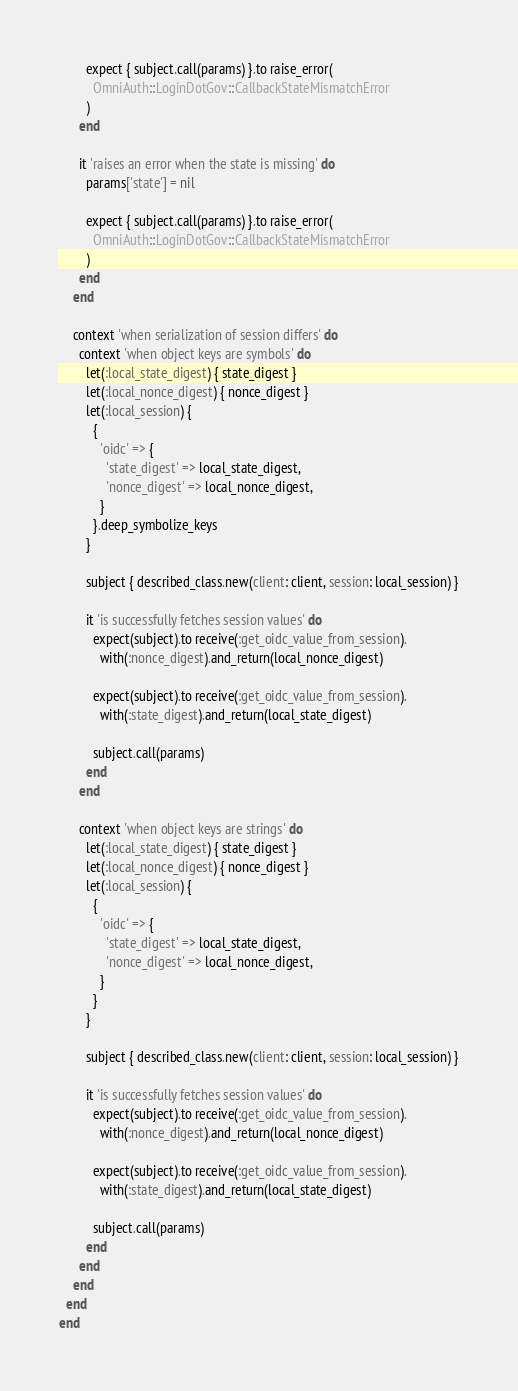Convert code to text. <code><loc_0><loc_0><loc_500><loc_500><_Ruby_>        expect { subject.call(params) }.to raise_error(
          OmniAuth::LoginDotGov::CallbackStateMismatchError
        )
      end

      it 'raises an error when the state is missing' do
        params['state'] = nil

        expect { subject.call(params) }.to raise_error(
          OmniAuth::LoginDotGov::CallbackStateMismatchError
        )
      end
    end

    context 'when serialization of session differs' do
      context 'when object keys are symbols' do
        let(:local_state_digest) { state_digest }
        let(:local_nonce_digest) { nonce_digest }
        let(:local_session) {
          {
            'oidc' => {
              'state_digest' => local_state_digest,
              'nonce_digest' => local_nonce_digest,
            }
          }.deep_symbolize_keys
        }

        subject { described_class.new(client: client, session: local_session) }

        it 'is successfully fetches session values' do
          expect(subject).to receive(:get_oidc_value_from_session).
            with(:nonce_digest).and_return(local_nonce_digest)

          expect(subject).to receive(:get_oidc_value_from_session).
            with(:state_digest).and_return(local_state_digest)

          subject.call(params)
        end
      end

      context 'when object keys are strings' do
        let(:local_state_digest) { state_digest }
        let(:local_nonce_digest) { nonce_digest }
        let(:local_session) {
          {
            'oidc' => {
              'state_digest' => local_state_digest,
              'nonce_digest' => local_nonce_digest,
            }
          }
        }

        subject { described_class.new(client: client, session: local_session) }

        it 'is successfully fetches session values' do
          expect(subject).to receive(:get_oidc_value_from_session).
            with(:nonce_digest).and_return(local_nonce_digest)

          expect(subject).to receive(:get_oidc_value_from_session).
            with(:state_digest).and_return(local_state_digest)

          subject.call(params)
        end
      end
    end
  end
end
</code> 